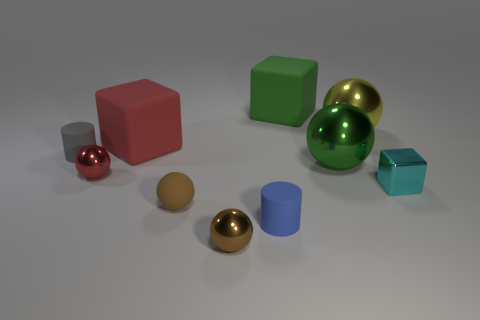What is the color of the other cylinder that is made of the same material as the small blue cylinder?
Make the answer very short. Gray. Is there a small red metal sphere behind the rubber object that is in front of the brown matte sphere?
Your response must be concise. Yes. What is the color of the other rubber cylinder that is the same size as the gray cylinder?
Make the answer very short. Blue. How many objects are either tiny red objects or large yellow shiny spheres?
Offer a terse response. 2. What is the size of the shiny ball that is in front of the rubber cylinder that is on the right side of the small rubber cylinder that is on the left side of the red rubber cube?
Make the answer very short. Small. What number of matte objects have the same color as the small cube?
Ensure brevity in your answer.  0. What number of small cyan objects have the same material as the big green ball?
Offer a very short reply. 1. How many objects are either green things or blocks to the right of the red block?
Offer a terse response. 3. What color is the matte cylinder to the left of the red thing that is in front of the big rubber object that is in front of the yellow object?
Your answer should be compact. Gray. How big is the rubber cube to the right of the brown matte thing?
Ensure brevity in your answer.  Large. 